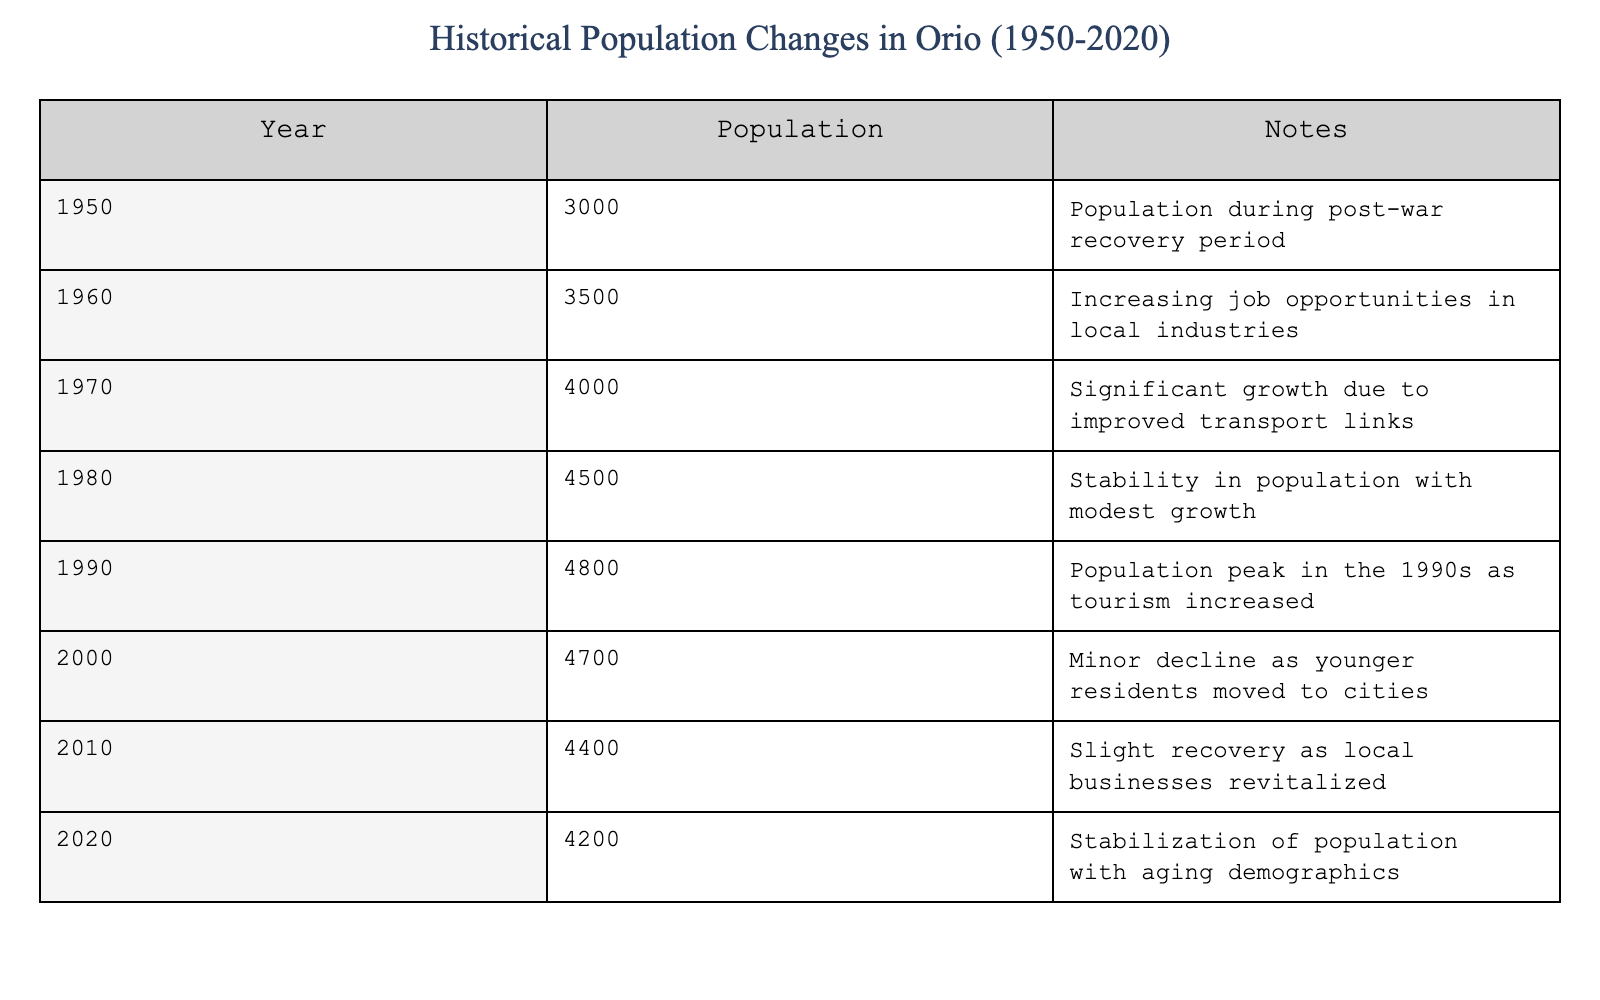What was the population of Orio in 1950? According to the table, the population listed for the year 1950 is 3000.
Answer: 3000 What was the highest population recorded between 1950 and 2020? The table indicates that the peak population was 4800 in 1990.
Answer: 4800 How much did the population decrease from 2000 to 2010? The population in 2000 was 4700 and in 2010 it was 4400. The difference is 4700 - 4400 = 300.
Answer: 300 Is it true that the population increased every decade from 1950 to 1990? Observing the table, the population increased from 1950 to 1990, confirming that it indeed rose each decade within this range.
Answer: Yes What was the population change from 1990 to 2000? The population in 1990 was 4800 and in 2000 it decreased to 4700, which shows a decline of 100.
Answer: 100 (decrease) What is the average population over the entire period from 1950 to 2020? To find the average, add all the population values: 3000 + 3500 + 4000 + 4500 + 4800 + 4700 + 4400 + 4200 = 33600. There are 8 data points, so the average is 33600 / 8 = 4200.
Answer: 4200 Did the population stabilize at any point between 2010 and 2020? The population decreased slightly from 4400 in 2010 to 4200 in 2020, indicating it did not stabilize but rather experienced a decline.
Answer: No What decade saw the greatest rate of population growth? The population increased most significantly during the 1960s, growing from 3000 in 1950 to 3500 in 1960, reflecting a 500 increase.
Answer: 1960s What was the overall trend in population from 1950 to 2020? The table shows a general trend of growth until 1990, followed by a decline until 2020, indicating a complex trend of growth then decline.
Answer: Growth then decline Was there a population recovery after the decline from 2000 to 2010? In 2010, the population was slightly higher than in 2000, showing a recovery from 4700 to 4400, despite still being below the peak.
Answer: Yes 